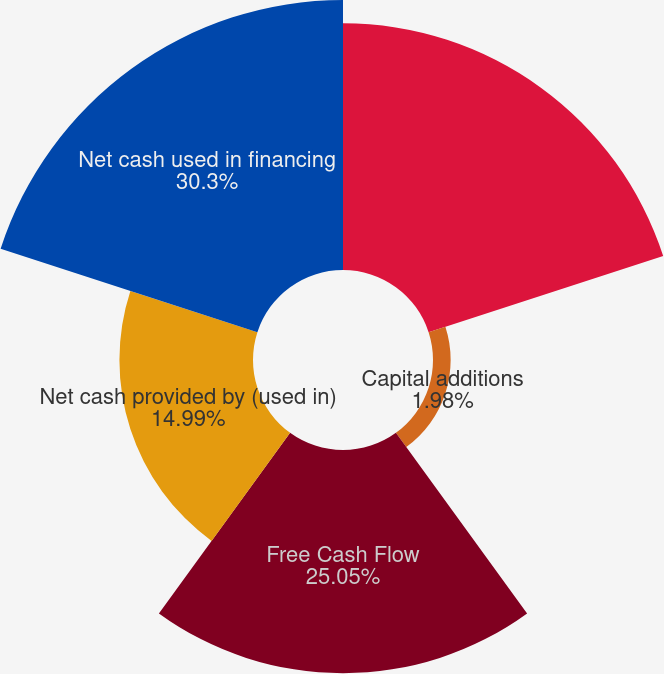Convert chart. <chart><loc_0><loc_0><loc_500><loc_500><pie_chart><fcel>Net cash provided by operating<fcel>Capital additions<fcel>Free Cash Flow<fcel>Net cash provided by (used in)<fcel>Net cash used in financing<nl><fcel>27.68%<fcel>1.98%<fcel>25.05%<fcel>14.99%<fcel>30.3%<nl></chart> 